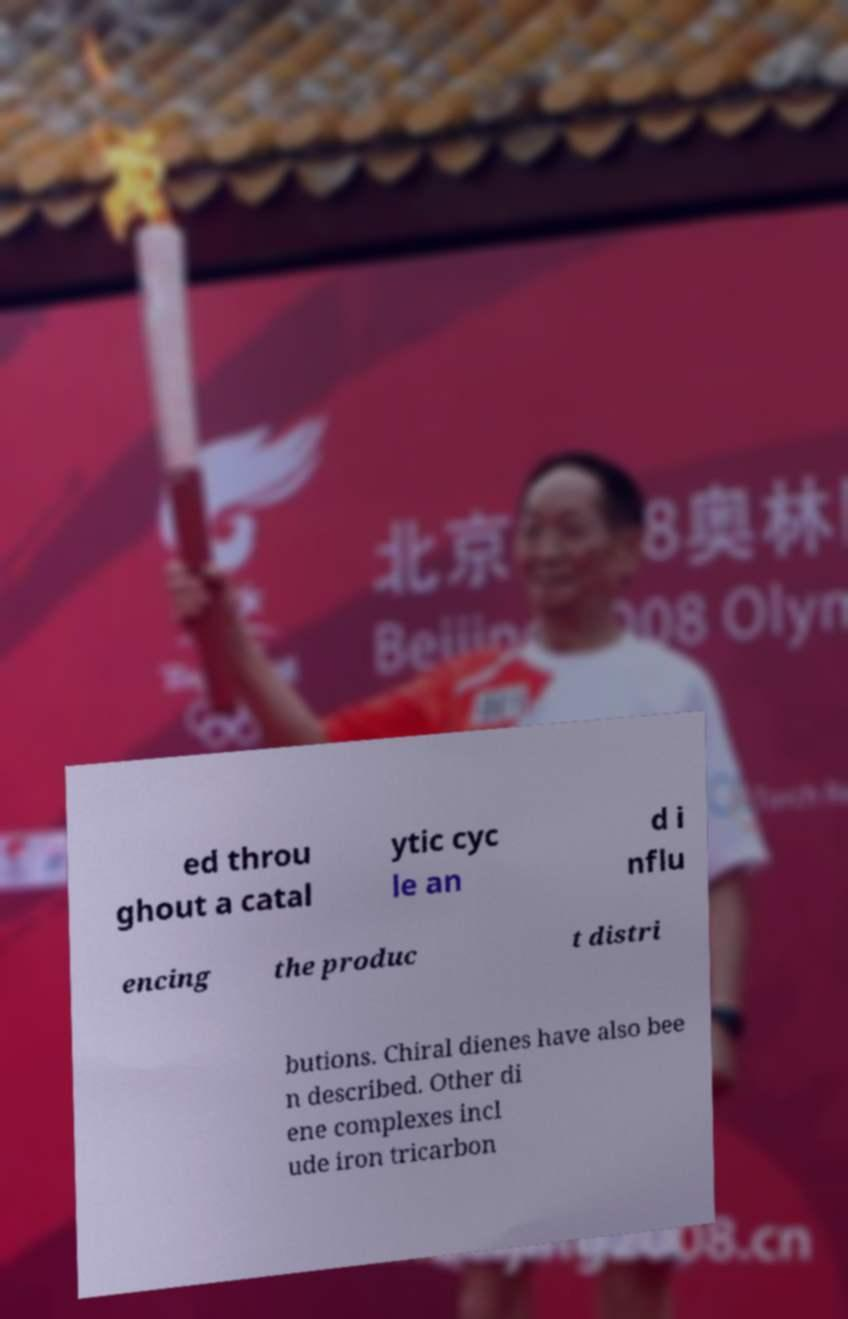What messages or text are displayed in this image? I need them in a readable, typed format. ed throu ghout a catal ytic cyc le an d i nflu encing the produc t distri butions. Chiral dienes have also bee n described. Other di ene complexes incl ude iron tricarbon 